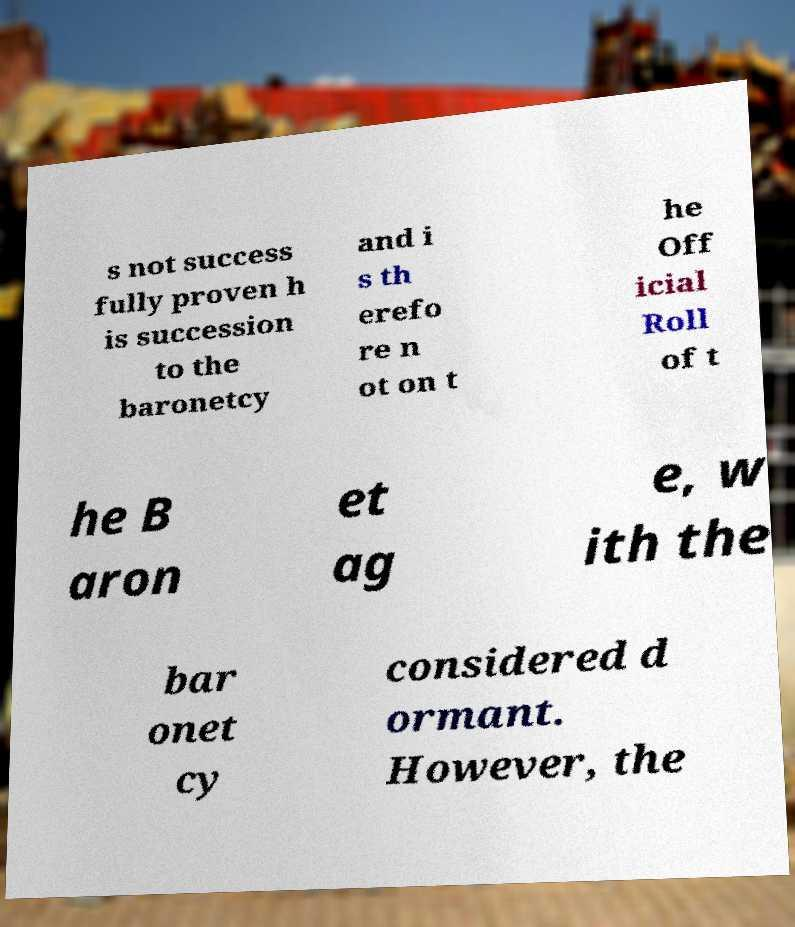Please read and relay the text visible in this image. What does it say? s not success fully proven h is succession to the baronetcy and i s th erefo re n ot on t he Off icial Roll of t he B aron et ag e, w ith the bar onet cy considered d ormant. However, the 